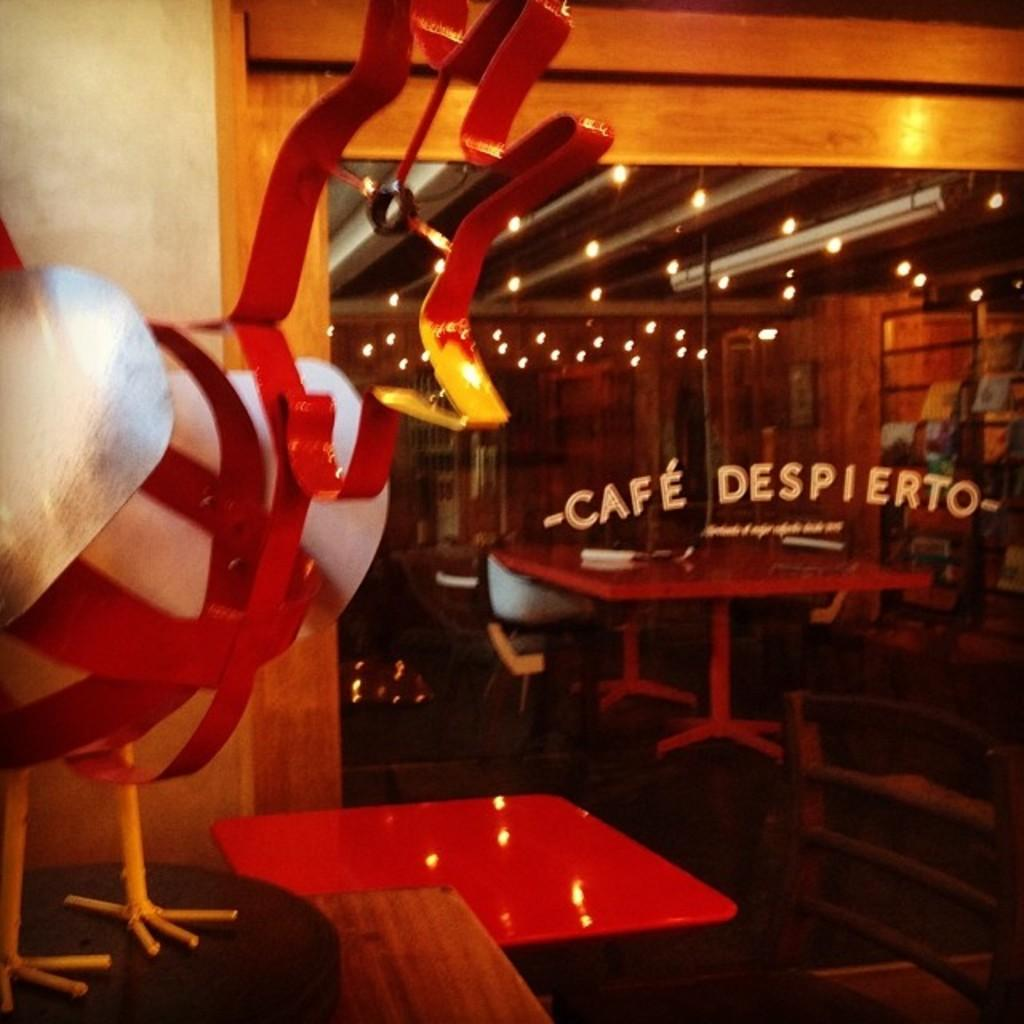What is the main subject in the foreground of the image? There is a model of a hen in the foreground of the image. What can be seen behind the model? There are empty tables behind the model. What information can be gathered from the doors in front of the tables? There is a cafe name on the doors in front of the tables. What type of statement can be heard from the model of the hen in the image? There is no statement being made by the model of the hen in the image, as it is an inanimate object. 